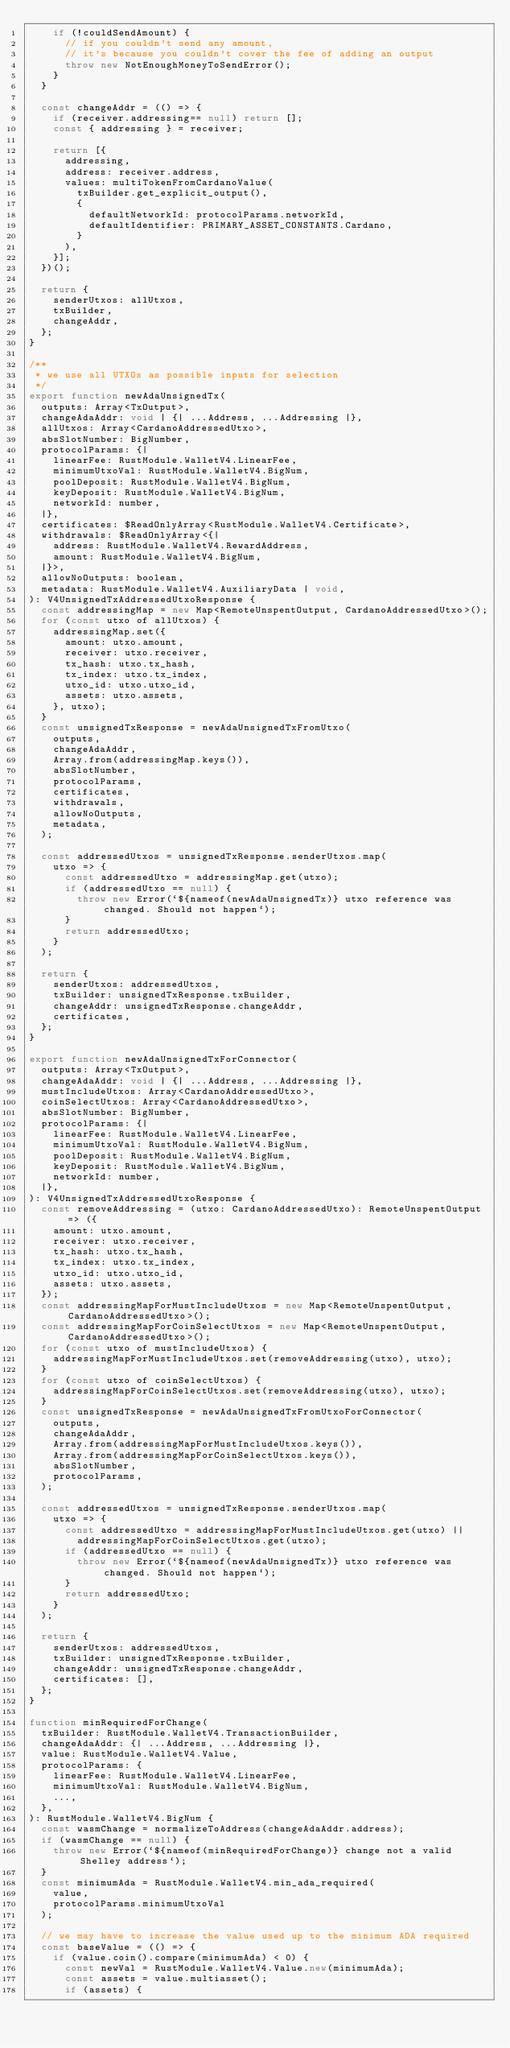<code> <loc_0><loc_0><loc_500><loc_500><_JavaScript_>    if (!couldSendAmount) {
      // if you couldn't send any amount,
      // it's because you couldn't cover the fee of adding an output
      throw new NotEnoughMoneyToSendError();
    }
  }

  const changeAddr = (() => {
    if (receiver.addressing== null) return [];
    const { addressing } = receiver;

    return [{
      addressing,
      address: receiver.address,
      values: multiTokenFromCardanoValue(
        txBuilder.get_explicit_output(),
        {
          defaultNetworkId: protocolParams.networkId,
          defaultIdentifier: PRIMARY_ASSET_CONSTANTS.Cardano,
        }
      ),
    }];
  })();

  return {
    senderUtxos: allUtxos,
    txBuilder,
    changeAddr,
  };
}

/**
 * we use all UTXOs as possible inputs for selection
 */
export function newAdaUnsignedTx(
  outputs: Array<TxOutput>,
  changeAdaAddr: void | {| ...Address, ...Addressing |},
  allUtxos: Array<CardanoAddressedUtxo>,
  absSlotNumber: BigNumber,
  protocolParams: {|
    linearFee: RustModule.WalletV4.LinearFee,
    minimumUtxoVal: RustModule.WalletV4.BigNum,
    poolDeposit: RustModule.WalletV4.BigNum,
    keyDeposit: RustModule.WalletV4.BigNum,
    networkId: number,
  |},
  certificates: $ReadOnlyArray<RustModule.WalletV4.Certificate>,
  withdrawals: $ReadOnlyArray<{|
    address: RustModule.WalletV4.RewardAddress,
    amount: RustModule.WalletV4.BigNum,
  |}>,
  allowNoOutputs: boolean,
  metadata: RustModule.WalletV4.AuxiliaryData | void,
): V4UnsignedTxAddressedUtxoResponse {
  const addressingMap = new Map<RemoteUnspentOutput, CardanoAddressedUtxo>();
  for (const utxo of allUtxos) {
    addressingMap.set({
      amount: utxo.amount,
      receiver: utxo.receiver,
      tx_hash: utxo.tx_hash,
      tx_index: utxo.tx_index,
      utxo_id: utxo.utxo_id,
      assets: utxo.assets,
    }, utxo);
  }
  const unsignedTxResponse = newAdaUnsignedTxFromUtxo(
    outputs,
    changeAdaAddr,
    Array.from(addressingMap.keys()),
    absSlotNumber,
    protocolParams,
    certificates,
    withdrawals,
    allowNoOutputs,
    metadata,
  );

  const addressedUtxos = unsignedTxResponse.senderUtxos.map(
    utxo => {
      const addressedUtxo = addressingMap.get(utxo);
      if (addressedUtxo == null) {
        throw new Error(`${nameof(newAdaUnsignedTx)} utxo reference was changed. Should not happen`);
      }
      return addressedUtxo;
    }
  );

  return {
    senderUtxos: addressedUtxos,
    txBuilder: unsignedTxResponse.txBuilder,
    changeAddr: unsignedTxResponse.changeAddr,
    certificates,
  };
}

export function newAdaUnsignedTxForConnector(
  outputs: Array<TxOutput>,
  changeAdaAddr: void | {| ...Address, ...Addressing |},
  mustIncludeUtxos: Array<CardanoAddressedUtxo>,
  coinSelectUtxos: Array<CardanoAddressedUtxo>,
  absSlotNumber: BigNumber,
  protocolParams: {|
    linearFee: RustModule.WalletV4.LinearFee,
    minimumUtxoVal: RustModule.WalletV4.BigNum,
    poolDeposit: RustModule.WalletV4.BigNum,
    keyDeposit: RustModule.WalletV4.BigNum,
    networkId: number,
  |},
): V4UnsignedTxAddressedUtxoResponse {
  const removeAddressing = (utxo: CardanoAddressedUtxo): RemoteUnspentOutput => ({
    amount: utxo.amount,
    receiver: utxo.receiver,
    tx_hash: utxo.tx_hash,
    tx_index: utxo.tx_index,
    utxo_id: utxo.utxo_id,
    assets: utxo.assets,
  });
  const addressingMapForMustIncludeUtxos = new Map<RemoteUnspentOutput, CardanoAddressedUtxo>();
  const addressingMapForCoinSelectUtxos = new Map<RemoteUnspentOutput, CardanoAddressedUtxo>();
  for (const utxo of mustIncludeUtxos) {
    addressingMapForMustIncludeUtxos.set(removeAddressing(utxo), utxo);
  }
  for (const utxo of coinSelectUtxos) {
    addressingMapForCoinSelectUtxos.set(removeAddressing(utxo), utxo);
  }
  const unsignedTxResponse = newAdaUnsignedTxFromUtxoForConnector(
    outputs,
    changeAdaAddr,
    Array.from(addressingMapForMustIncludeUtxos.keys()),
    Array.from(addressingMapForCoinSelectUtxos.keys()),
    absSlotNumber,
    protocolParams,
  );

  const addressedUtxos = unsignedTxResponse.senderUtxos.map(
    utxo => {
      const addressedUtxo = addressingMapForMustIncludeUtxos.get(utxo) ||
        addressingMapForCoinSelectUtxos.get(utxo);
      if (addressedUtxo == null) {
        throw new Error(`${nameof(newAdaUnsignedTx)} utxo reference was changed. Should not happen`);
      }
      return addressedUtxo;
    }
  );

  return {
    senderUtxos: addressedUtxos,
    txBuilder: unsignedTxResponse.txBuilder,
    changeAddr: unsignedTxResponse.changeAddr,
    certificates: [],
  };
}

function minRequiredForChange(
  txBuilder: RustModule.WalletV4.TransactionBuilder,
  changeAdaAddr: {| ...Address, ...Addressing |},
  value: RustModule.WalletV4.Value,
  protocolParams: {
    linearFee: RustModule.WalletV4.LinearFee,
    minimumUtxoVal: RustModule.WalletV4.BigNum,
    ...,
  },
): RustModule.WalletV4.BigNum {
  const wasmChange = normalizeToAddress(changeAdaAddr.address);
  if (wasmChange == null) {
    throw new Error(`${nameof(minRequiredForChange)} change not a valid Shelley address`);
  }
  const minimumAda = RustModule.WalletV4.min_ada_required(
    value,
    protocolParams.minimumUtxoVal
  );

  // we may have to increase the value used up to the minimum ADA required
  const baseValue = (() => {
    if (value.coin().compare(minimumAda) < 0) {
      const newVal = RustModule.WalletV4.Value.new(minimumAda);
      const assets = value.multiasset();
      if (assets) {</code> 